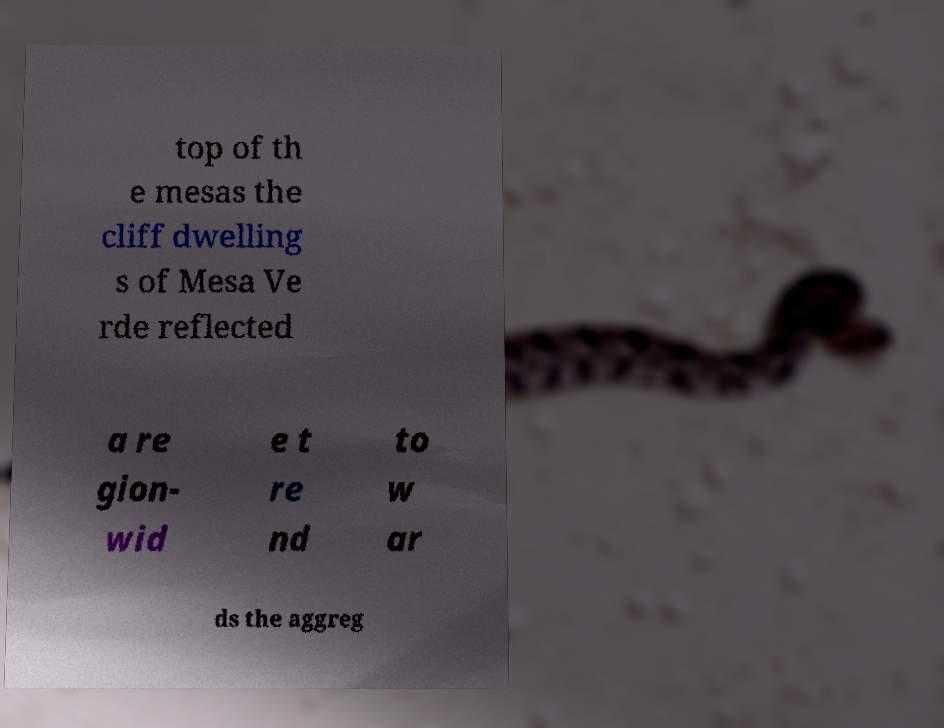What messages or text are displayed in this image? I need them in a readable, typed format. top of th e mesas the cliff dwelling s of Mesa Ve rde reflected a re gion- wid e t re nd to w ar ds the aggreg 